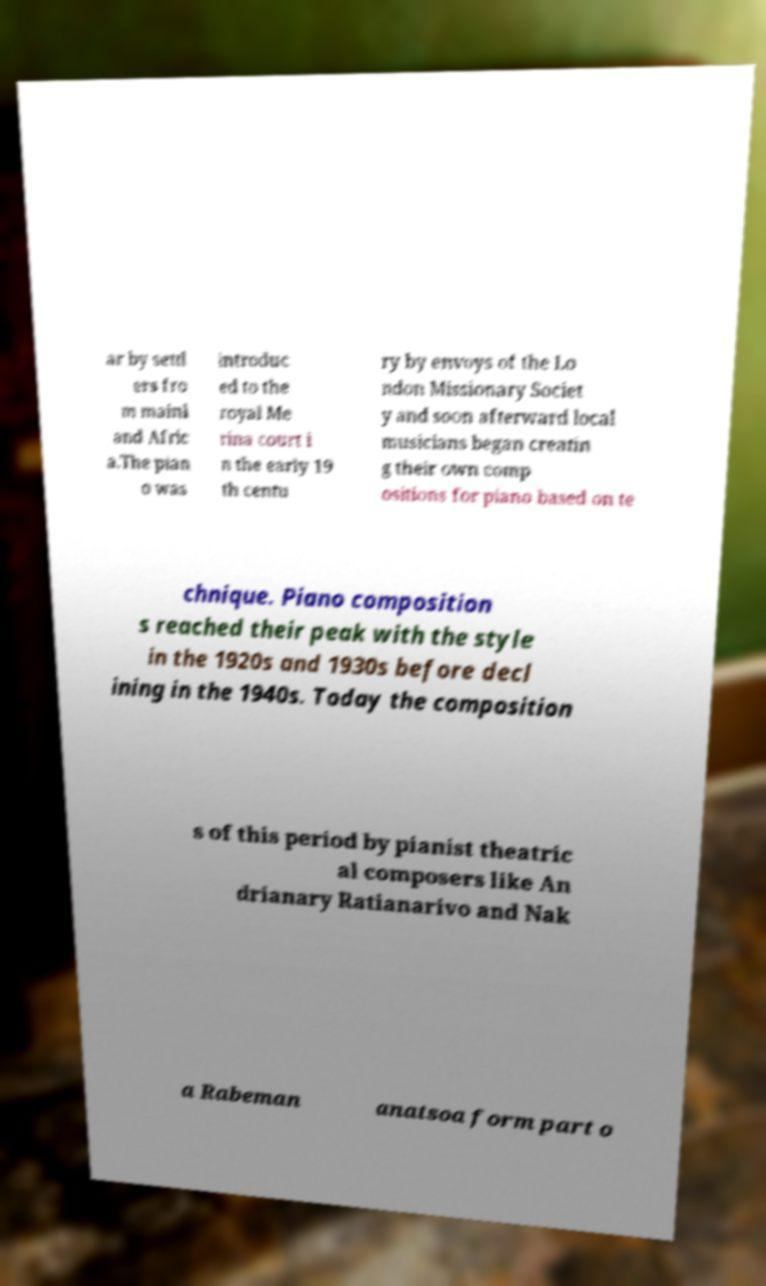I need the written content from this picture converted into text. Can you do that? ar by settl ers fro m mainl and Afric a.The pian o was introduc ed to the royal Me rina court i n the early 19 th centu ry by envoys of the Lo ndon Missionary Societ y and soon afterward local musicians began creatin g their own comp ositions for piano based on te chnique. Piano composition s reached their peak with the style in the 1920s and 1930s before decl ining in the 1940s. Today the composition s of this period by pianist theatric al composers like An drianary Ratianarivo and Nak a Rabeman anatsoa form part o 